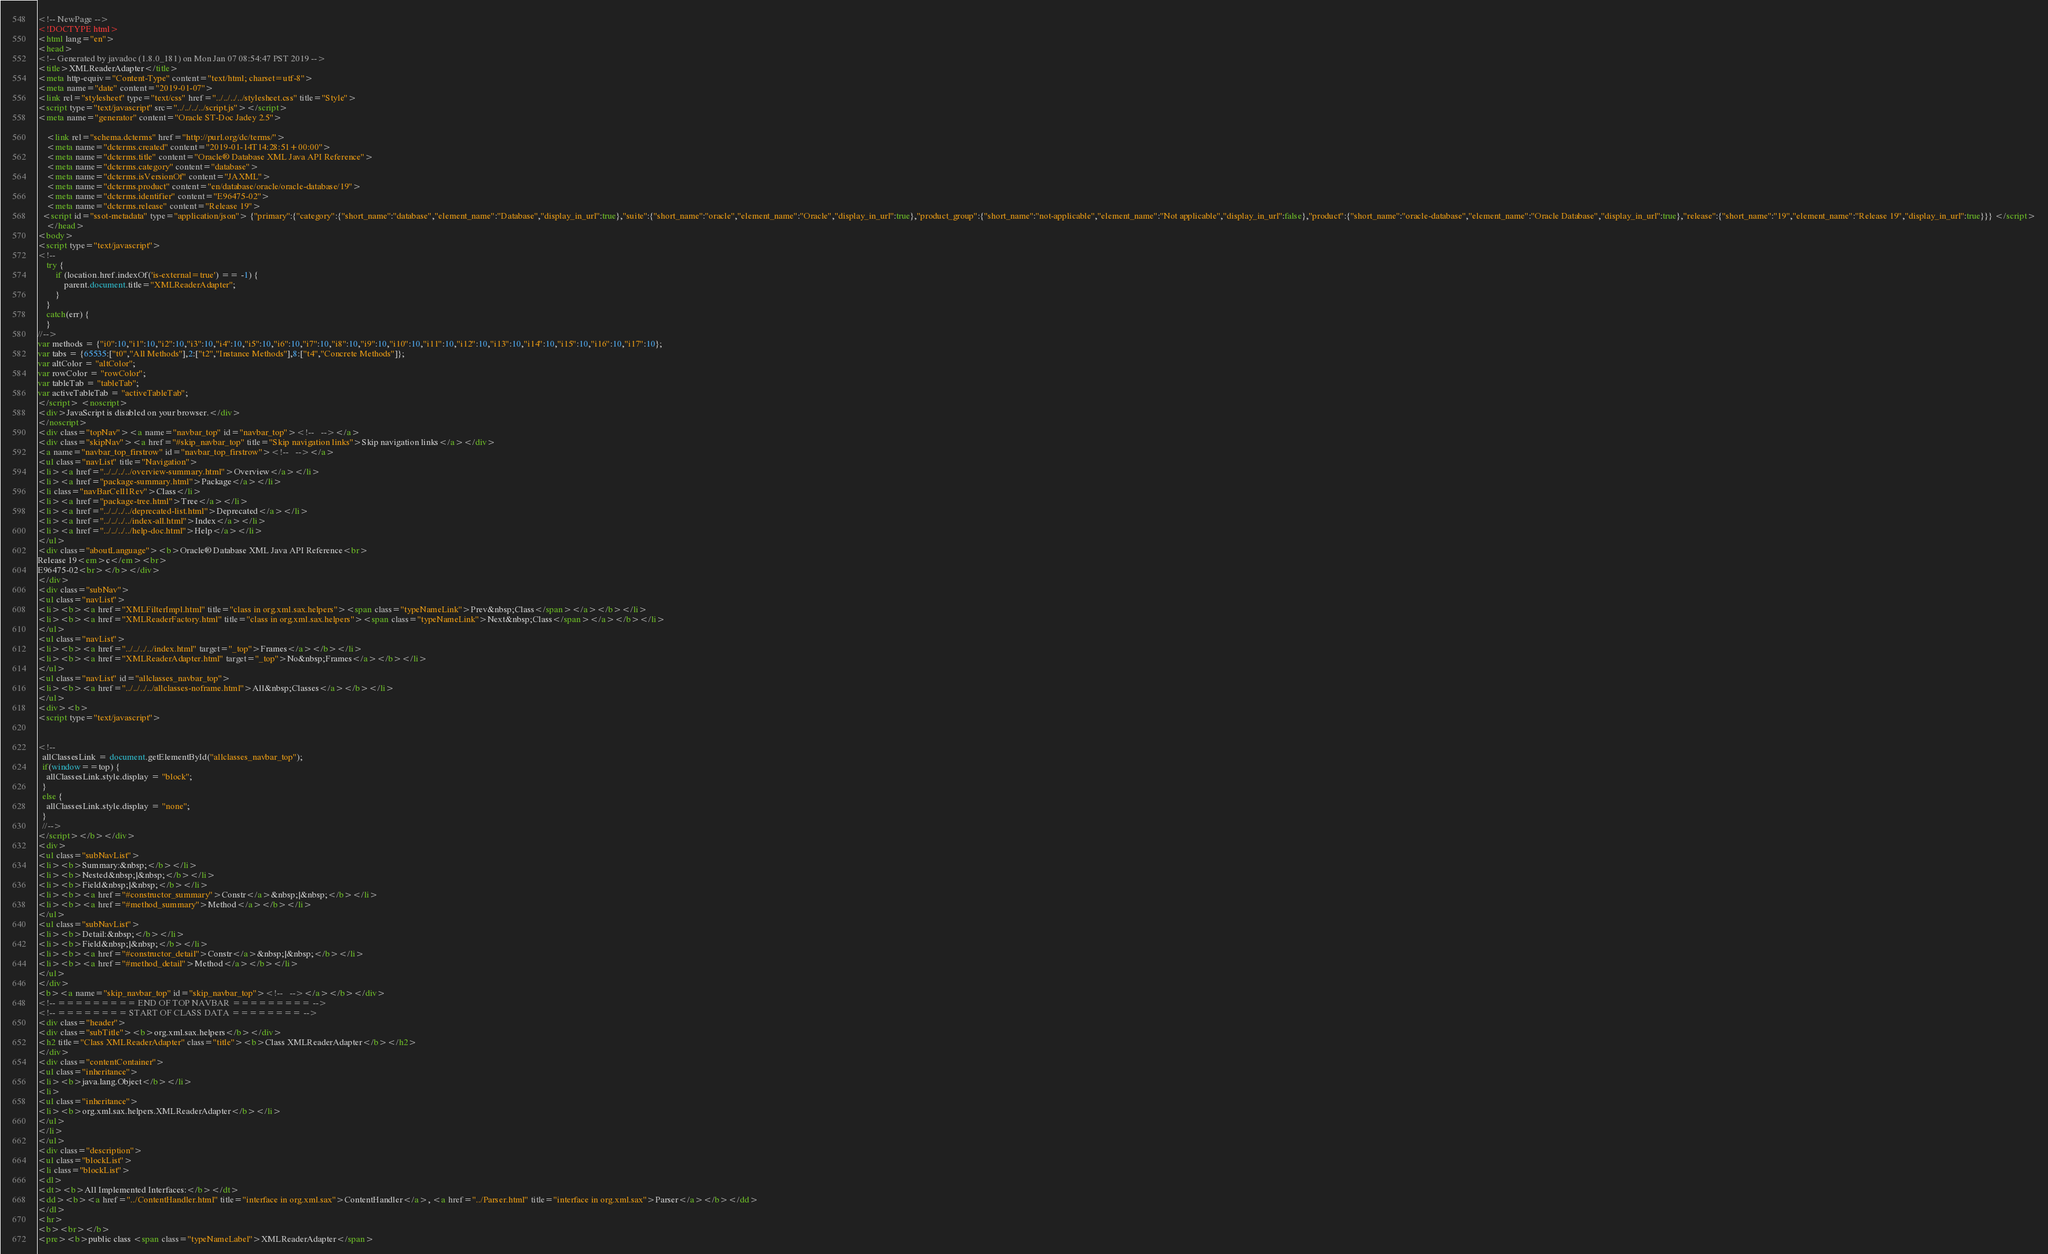<code> <loc_0><loc_0><loc_500><loc_500><_HTML_><!-- NewPage -->
<!DOCTYPE html>
<html lang="en">
<head>
<!-- Generated by javadoc (1.8.0_181) on Mon Jan 07 08:54:47 PST 2019 -->
<title>XMLReaderAdapter</title>
<meta http-equiv="Content-Type" content="text/html; charset=utf-8">
<meta name="date" content="2019-01-07">
<link rel="stylesheet" type="text/css" href="../../../../stylesheet.css" title="Style">
<script type="text/javascript" src="../../../../script.js"></script>
<meta name="generator" content="Oracle ST-Doc Jadey 2.5">

    <link rel="schema.dcterms" href="http://purl.org/dc/terms/">
    <meta name="dcterms.created" content="2019-01-14T14:28:51+00:00">
    <meta name="dcterms.title" content="Oracle® Database XML Java API Reference">
    <meta name="dcterms.category" content="database">
    <meta name="dcterms.isVersionOf" content="JAXML">
    <meta name="dcterms.product" content="en/database/oracle/oracle-database/19">
    <meta name="dcterms.identifier" content="E96475-02">
    <meta name="dcterms.release" content="Release 19">
  <script id="ssot-metadata" type="application/json"> {"primary":{"category":{"short_name":"database","element_name":"Database","display_in_url":true},"suite":{"short_name":"oracle","element_name":"Oracle","display_in_url":true},"product_group":{"short_name":"not-applicable","element_name":"Not applicable","display_in_url":false},"product":{"short_name":"oracle-database","element_name":"Oracle Database","display_in_url":true},"release":{"short_name":"19","element_name":"Release 19","display_in_url":true}}} </script>
    </head>
<body>
<script type="text/javascript">
<!--
    try {
        if (location.href.indexOf('is-external=true') == -1) {
            parent.document.title="XMLReaderAdapter";
        }
    }
    catch(err) {
    }
//-->
var methods = {"i0":10,"i1":10,"i2":10,"i3":10,"i4":10,"i5":10,"i6":10,"i7":10,"i8":10,"i9":10,"i10":10,"i11":10,"i12":10,"i13":10,"i14":10,"i15":10,"i16":10,"i17":10};
var tabs = {65535:["t0","All Methods"],2:["t2","Instance Methods"],8:["t4","Concrete Methods"]};
var altColor = "altColor";
var rowColor = "rowColor";
var tableTab = "tableTab";
var activeTableTab = "activeTableTab";
</script> <noscript>
<div>JavaScript is disabled on your browser.</div>
</noscript>
<div class="topNav"><a name="navbar_top" id="navbar_top"><!--   --></a>
<div class="skipNav"><a href="#skip_navbar_top" title="Skip navigation links">Skip navigation links</a></div>
<a name="navbar_top_firstrow" id="navbar_top_firstrow"><!--   --></a>
<ul class="navList" title="Navigation">
<li><a href="../../../../overview-summary.html">Overview</a></li>
<li><a href="package-summary.html">Package</a></li>
<li class="navBarCell1Rev">Class</li>
<li><a href="package-tree.html">Tree</a></li>
<li><a href="../../../../deprecated-list.html">Deprecated</a></li>
<li><a href="../../../../index-all.html">Index</a></li>
<li><a href="../../../../help-doc.html">Help</a></li>
</ul>
<div class="aboutLanguage"><b>Oracle® Database XML Java API Reference<br>
Release 19<em>c</em><br>
E96475-02<br></b></div>
</div>
<div class="subNav">
<ul class="navList">
<li><b><a href="XMLFilterImpl.html" title="class in org.xml.sax.helpers"><span class="typeNameLink">Prev&nbsp;Class</span></a></b></li>
<li><b><a href="XMLReaderFactory.html" title="class in org.xml.sax.helpers"><span class="typeNameLink">Next&nbsp;Class</span></a></b></li>
</ul>
<ul class="navList">
<li><b><a href="../../../../index.html" target="_top">Frames</a></b></li>
<li><b><a href="XMLReaderAdapter.html" target="_top">No&nbsp;Frames</a></b></li>
</ul>
<ul class="navList" id="allclasses_navbar_top">
<li><b><a href="../../../../allclasses-noframe.html">All&nbsp;Classes</a></b></li>
</ul>
<div><b>
<script type="text/javascript">


<!--
  allClassesLink = document.getElementById("allclasses_navbar_top");
  if(window==top) {
    allClassesLink.style.display = "block";
  }
  else {
    allClassesLink.style.display = "none";
  }
  //-->
</script></b></div>
<div>
<ul class="subNavList">
<li><b>Summary:&nbsp;</b></li>
<li><b>Nested&nbsp;|&nbsp;</b></li>
<li><b>Field&nbsp;|&nbsp;</b></li>
<li><b><a href="#constructor_summary">Constr</a>&nbsp;|&nbsp;</b></li>
<li><b><a href="#method_summary">Method</a></b></li>
</ul>
<ul class="subNavList">
<li><b>Detail:&nbsp;</b></li>
<li><b>Field&nbsp;|&nbsp;</b></li>
<li><b><a href="#constructor_detail">Constr</a>&nbsp;|&nbsp;</b></li>
<li><b><a href="#method_detail">Method</a></b></li>
</ul>
</div>
<b><a name="skip_navbar_top" id="skip_navbar_top"><!--   --></a></b></div>
<!-- ========= END OF TOP NAVBAR ========= -->
<!-- ======== START OF CLASS DATA ======== -->
<div class="header">
<div class="subTitle"><b>org.xml.sax.helpers</b></div>
<h2 title="Class XMLReaderAdapter" class="title"><b>Class XMLReaderAdapter</b></h2>
</div>
<div class="contentContainer">
<ul class="inheritance">
<li><b>java.lang.Object</b></li>
<li>
<ul class="inheritance">
<li><b>org.xml.sax.helpers.XMLReaderAdapter</b></li>
</ul>
</li>
</ul>
<div class="description">
<ul class="blockList">
<li class="blockList">
<dl>
<dt><b>All Implemented Interfaces:</b></dt>
<dd><b><a href="../ContentHandler.html" title="interface in org.xml.sax">ContentHandler</a>, <a href="../Parser.html" title="interface in org.xml.sax">Parser</a></b></dd>
</dl>
<hr>
<b><br></b>
<pre><b>public class <span class="typeNameLabel">XMLReaderAdapter</span></code> 